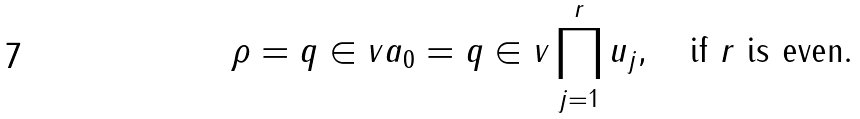Convert formula to latex. <formula><loc_0><loc_0><loc_500><loc_500>\rho = q \in v a _ { 0 } = q \in v \prod _ { j = 1 } ^ { r } u _ { j } , \quad \text {if $r$ is even} .</formula> 